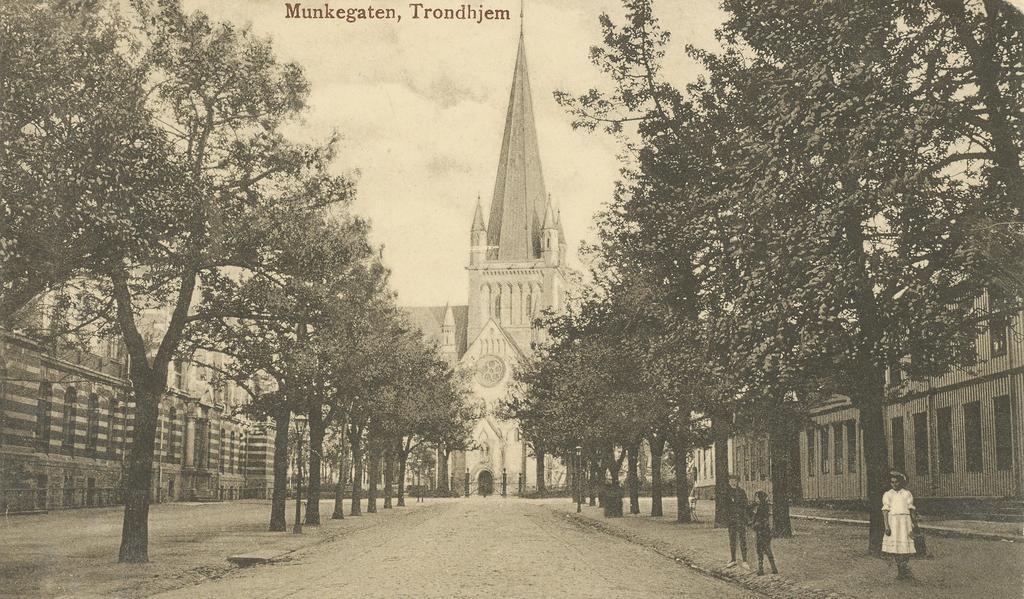Please provide a concise description of this image. In the middle of the image few people are standing. Behind them there are some trees and buildings. At the top of the image there are some clouds in the sky and we can see some alphabets. 